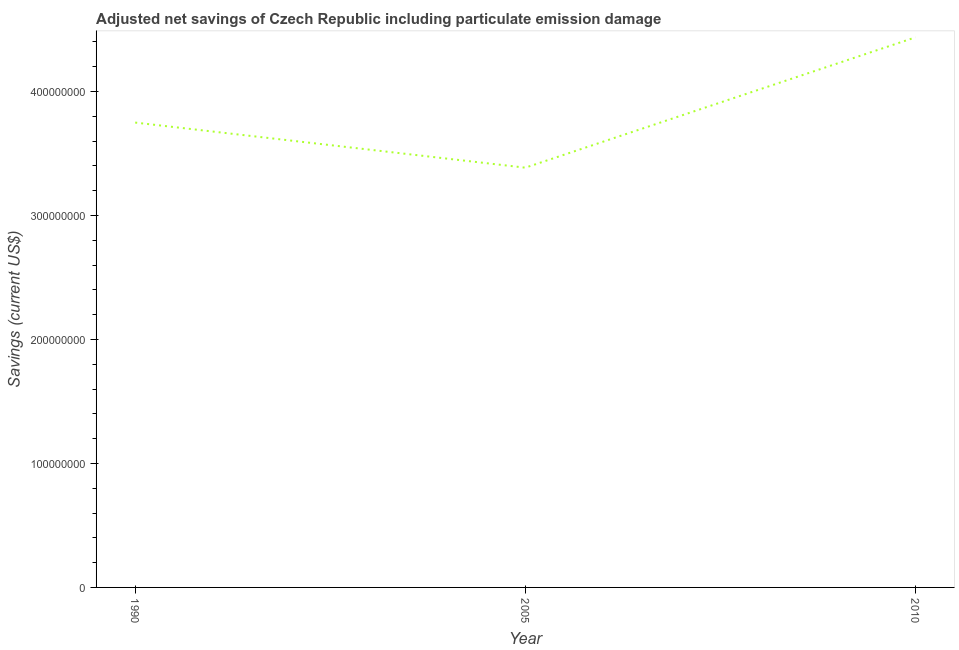What is the adjusted net savings in 1990?
Your answer should be very brief. 3.75e+08. Across all years, what is the maximum adjusted net savings?
Your response must be concise. 4.44e+08. Across all years, what is the minimum adjusted net savings?
Your answer should be very brief. 3.39e+08. In which year was the adjusted net savings maximum?
Offer a terse response. 2010. In which year was the adjusted net savings minimum?
Ensure brevity in your answer.  2005. What is the sum of the adjusted net savings?
Offer a very short reply. 1.16e+09. What is the difference between the adjusted net savings in 1990 and 2010?
Offer a very short reply. -6.87e+07. What is the average adjusted net savings per year?
Keep it short and to the point. 3.86e+08. What is the median adjusted net savings?
Ensure brevity in your answer.  3.75e+08. Do a majority of the years between 1990 and 2010 (inclusive) have adjusted net savings greater than 220000000 US$?
Offer a terse response. Yes. What is the ratio of the adjusted net savings in 1990 to that in 2005?
Provide a short and direct response. 1.11. Is the adjusted net savings in 2005 less than that in 2010?
Offer a terse response. Yes. Is the difference between the adjusted net savings in 2005 and 2010 greater than the difference between any two years?
Offer a terse response. Yes. What is the difference between the highest and the second highest adjusted net savings?
Make the answer very short. 6.87e+07. Is the sum of the adjusted net savings in 1990 and 2005 greater than the maximum adjusted net savings across all years?
Make the answer very short. Yes. What is the difference between the highest and the lowest adjusted net savings?
Offer a terse response. 1.05e+08. Does the adjusted net savings monotonically increase over the years?
Give a very brief answer. No. What is the difference between two consecutive major ticks on the Y-axis?
Give a very brief answer. 1.00e+08. Does the graph contain any zero values?
Offer a terse response. No. Does the graph contain grids?
Your response must be concise. No. What is the title of the graph?
Your answer should be compact. Adjusted net savings of Czech Republic including particulate emission damage. What is the label or title of the Y-axis?
Keep it short and to the point. Savings (current US$). What is the Savings (current US$) of 1990?
Provide a short and direct response. 3.75e+08. What is the Savings (current US$) of 2005?
Keep it short and to the point. 3.39e+08. What is the Savings (current US$) of 2010?
Provide a succinct answer. 4.44e+08. What is the difference between the Savings (current US$) in 1990 and 2005?
Ensure brevity in your answer.  3.64e+07. What is the difference between the Savings (current US$) in 1990 and 2010?
Your response must be concise. -6.87e+07. What is the difference between the Savings (current US$) in 2005 and 2010?
Provide a succinct answer. -1.05e+08. What is the ratio of the Savings (current US$) in 1990 to that in 2005?
Ensure brevity in your answer.  1.11. What is the ratio of the Savings (current US$) in 1990 to that in 2010?
Offer a very short reply. 0.84. What is the ratio of the Savings (current US$) in 2005 to that in 2010?
Your answer should be compact. 0.76. 